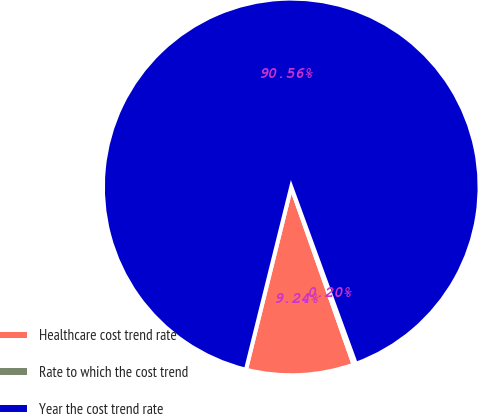Convert chart to OTSL. <chart><loc_0><loc_0><loc_500><loc_500><pie_chart><fcel>Healthcare cost trend rate<fcel>Rate to which the cost trend<fcel>Year the cost trend rate<nl><fcel>9.24%<fcel>0.2%<fcel>90.56%<nl></chart> 